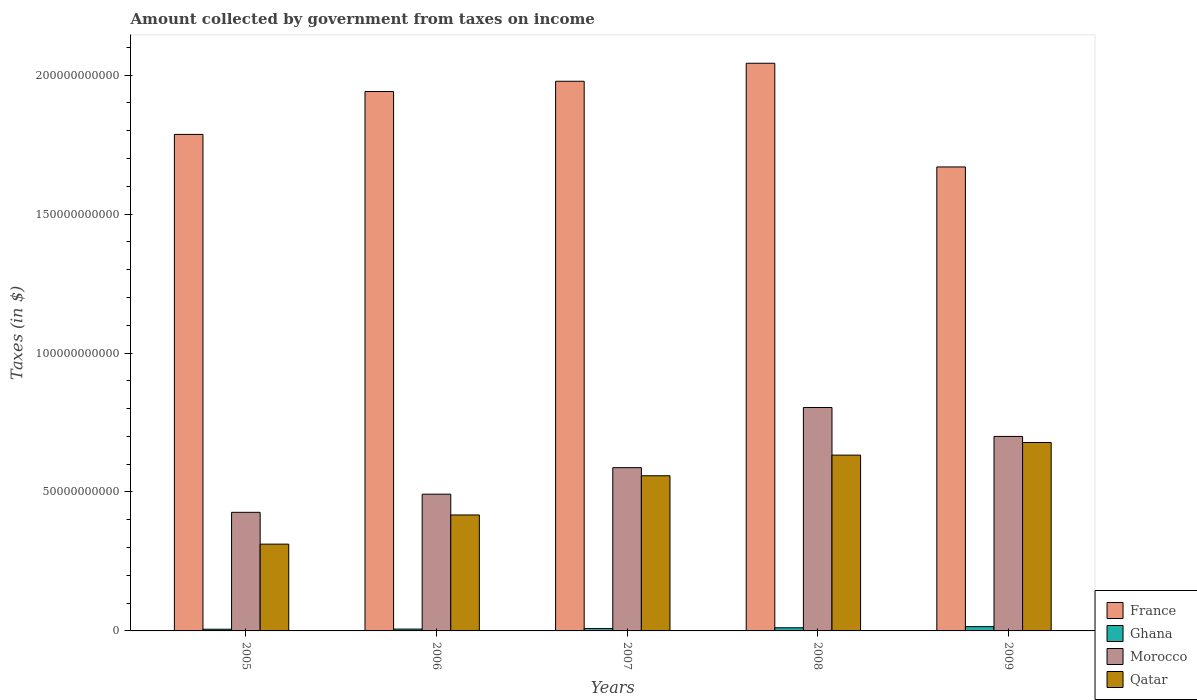How many different coloured bars are there?
Provide a succinct answer. 4. How many groups of bars are there?
Offer a very short reply. 5. How many bars are there on the 1st tick from the left?
Your answer should be compact. 4. How many bars are there on the 1st tick from the right?
Ensure brevity in your answer.  4. What is the label of the 4th group of bars from the left?
Give a very brief answer. 2008. What is the amount collected by government from taxes on income in Morocco in 2007?
Provide a succinct answer. 5.88e+1. Across all years, what is the maximum amount collected by government from taxes on income in Ghana?
Offer a very short reply. 1.54e+09. Across all years, what is the minimum amount collected by government from taxes on income in Morocco?
Your answer should be very brief. 4.27e+1. In which year was the amount collected by government from taxes on income in Morocco minimum?
Make the answer very short. 2005. What is the total amount collected by government from taxes on income in France in the graph?
Keep it short and to the point. 9.42e+11. What is the difference between the amount collected by government from taxes on income in France in 2006 and that in 2007?
Give a very brief answer. -3.69e+09. What is the difference between the amount collected by government from taxes on income in Morocco in 2008 and the amount collected by government from taxes on income in Qatar in 2005?
Keep it short and to the point. 4.92e+1. What is the average amount collected by government from taxes on income in Ghana per year?
Make the answer very short. 9.60e+08. In the year 2007, what is the difference between the amount collected by government from taxes on income in Morocco and amount collected by government from taxes on income in Qatar?
Provide a succinct answer. 2.91e+09. In how many years, is the amount collected by government from taxes on income in France greater than 140000000000 $?
Your answer should be compact. 5. What is the ratio of the amount collected by government from taxes on income in France in 2006 to that in 2007?
Your answer should be very brief. 0.98. What is the difference between the highest and the second highest amount collected by government from taxes on income in Morocco?
Your answer should be compact. 1.04e+1. What is the difference between the highest and the lowest amount collected by government from taxes on income in Morocco?
Make the answer very short. 3.77e+1. In how many years, is the amount collected by government from taxes on income in Qatar greater than the average amount collected by government from taxes on income in Qatar taken over all years?
Provide a succinct answer. 3. What does the 3rd bar from the left in 2006 represents?
Offer a terse response. Morocco. What does the 2nd bar from the right in 2008 represents?
Make the answer very short. Morocco. Is it the case that in every year, the sum of the amount collected by government from taxes on income in Ghana and amount collected by government from taxes on income in Morocco is greater than the amount collected by government from taxes on income in Qatar?
Keep it short and to the point. Yes. How many bars are there?
Your response must be concise. 20. Are all the bars in the graph horizontal?
Your answer should be compact. No. How many years are there in the graph?
Offer a terse response. 5. Does the graph contain grids?
Give a very brief answer. No. How many legend labels are there?
Offer a terse response. 4. How are the legend labels stacked?
Provide a short and direct response. Vertical. What is the title of the graph?
Ensure brevity in your answer.  Amount collected by government from taxes on income. What is the label or title of the X-axis?
Keep it short and to the point. Years. What is the label or title of the Y-axis?
Keep it short and to the point. Taxes (in $). What is the Taxes (in $) in France in 2005?
Make the answer very short. 1.79e+11. What is the Taxes (in $) in Ghana in 2005?
Provide a short and direct response. 6.09e+08. What is the Taxes (in $) in Morocco in 2005?
Ensure brevity in your answer.  4.27e+1. What is the Taxes (in $) of Qatar in 2005?
Make the answer very short. 3.12e+1. What is the Taxes (in $) of France in 2006?
Ensure brevity in your answer.  1.94e+11. What is the Taxes (in $) of Ghana in 2006?
Keep it short and to the point. 6.58e+08. What is the Taxes (in $) in Morocco in 2006?
Offer a very short reply. 4.92e+1. What is the Taxes (in $) in Qatar in 2006?
Your response must be concise. 4.17e+1. What is the Taxes (in $) in France in 2007?
Give a very brief answer. 1.98e+11. What is the Taxes (in $) in Ghana in 2007?
Provide a succinct answer. 8.57e+08. What is the Taxes (in $) in Morocco in 2007?
Your response must be concise. 5.88e+1. What is the Taxes (in $) in Qatar in 2007?
Give a very brief answer. 5.58e+1. What is the Taxes (in $) in France in 2008?
Your answer should be compact. 2.04e+11. What is the Taxes (in $) in Ghana in 2008?
Ensure brevity in your answer.  1.13e+09. What is the Taxes (in $) in Morocco in 2008?
Provide a succinct answer. 8.04e+1. What is the Taxes (in $) in Qatar in 2008?
Provide a short and direct response. 6.33e+1. What is the Taxes (in $) of France in 2009?
Ensure brevity in your answer.  1.67e+11. What is the Taxes (in $) of Ghana in 2009?
Your answer should be very brief. 1.54e+09. What is the Taxes (in $) in Morocco in 2009?
Provide a short and direct response. 7.00e+1. What is the Taxes (in $) in Qatar in 2009?
Offer a terse response. 6.78e+1. Across all years, what is the maximum Taxes (in $) of France?
Your answer should be compact. 2.04e+11. Across all years, what is the maximum Taxes (in $) of Ghana?
Offer a very short reply. 1.54e+09. Across all years, what is the maximum Taxes (in $) in Morocco?
Give a very brief answer. 8.04e+1. Across all years, what is the maximum Taxes (in $) in Qatar?
Your answer should be compact. 6.78e+1. Across all years, what is the minimum Taxes (in $) in France?
Your answer should be compact. 1.67e+11. Across all years, what is the minimum Taxes (in $) of Ghana?
Your answer should be compact. 6.09e+08. Across all years, what is the minimum Taxes (in $) of Morocco?
Your answer should be compact. 4.27e+1. Across all years, what is the minimum Taxes (in $) in Qatar?
Your answer should be very brief. 3.12e+1. What is the total Taxes (in $) in France in the graph?
Provide a short and direct response. 9.42e+11. What is the total Taxes (in $) of Ghana in the graph?
Your response must be concise. 4.80e+09. What is the total Taxes (in $) of Morocco in the graph?
Provide a short and direct response. 3.01e+11. What is the total Taxes (in $) of Qatar in the graph?
Keep it short and to the point. 2.60e+11. What is the difference between the Taxes (in $) in France in 2005 and that in 2006?
Make the answer very short. -1.54e+1. What is the difference between the Taxes (in $) of Ghana in 2005 and that in 2006?
Provide a short and direct response. -4.90e+07. What is the difference between the Taxes (in $) of Morocco in 2005 and that in 2006?
Your response must be concise. -6.53e+09. What is the difference between the Taxes (in $) of Qatar in 2005 and that in 2006?
Keep it short and to the point. -1.05e+1. What is the difference between the Taxes (in $) of France in 2005 and that in 2007?
Provide a short and direct response. -1.91e+1. What is the difference between the Taxes (in $) of Ghana in 2005 and that in 2007?
Keep it short and to the point. -2.48e+08. What is the difference between the Taxes (in $) in Morocco in 2005 and that in 2007?
Offer a very short reply. -1.61e+1. What is the difference between the Taxes (in $) of Qatar in 2005 and that in 2007?
Your response must be concise. -2.46e+1. What is the difference between the Taxes (in $) of France in 2005 and that in 2008?
Your response must be concise. -2.56e+1. What is the difference between the Taxes (in $) of Ghana in 2005 and that in 2008?
Keep it short and to the point. -5.26e+08. What is the difference between the Taxes (in $) of Morocco in 2005 and that in 2008?
Your answer should be very brief. -3.77e+1. What is the difference between the Taxes (in $) in Qatar in 2005 and that in 2008?
Your answer should be very brief. -3.20e+1. What is the difference between the Taxes (in $) of France in 2005 and that in 2009?
Give a very brief answer. 1.17e+1. What is the difference between the Taxes (in $) of Ghana in 2005 and that in 2009?
Offer a terse response. -9.29e+08. What is the difference between the Taxes (in $) of Morocco in 2005 and that in 2009?
Offer a terse response. -2.73e+1. What is the difference between the Taxes (in $) of Qatar in 2005 and that in 2009?
Your answer should be compact. -3.66e+1. What is the difference between the Taxes (in $) of France in 2006 and that in 2007?
Your response must be concise. -3.69e+09. What is the difference between the Taxes (in $) in Ghana in 2006 and that in 2007?
Your answer should be very brief. -1.99e+08. What is the difference between the Taxes (in $) of Morocco in 2006 and that in 2007?
Offer a very short reply. -9.54e+09. What is the difference between the Taxes (in $) of Qatar in 2006 and that in 2007?
Your answer should be very brief. -1.41e+1. What is the difference between the Taxes (in $) of France in 2006 and that in 2008?
Provide a succinct answer. -1.02e+1. What is the difference between the Taxes (in $) of Ghana in 2006 and that in 2008?
Offer a very short reply. -4.77e+08. What is the difference between the Taxes (in $) in Morocco in 2006 and that in 2008?
Ensure brevity in your answer.  -3.12e+1. What is the difference between the Taxes (in $) in Qatar in 2006 and that in 2008?
Your answer should be compact. -2.15e+1. What is the difference between the Taxes (in $) of France in 2006 and that in 2009?
Offer a very short reply. 2.71e+1. What is the difference between the Taxes (in $) of Ghana in 2006 and that in 2009?
Provide a succinct answer. -8.80e+08. What is the difference between the Taxes (in $) of Morocco in 2006 and that in 2009?
Your answer should be compact. -2.08e+1. What is the difference between the Taxes (in $) in Qatar in 2006 and that in 2009?
Your answer should be compact. -2.61e+1. What is the difference between the Taxes (in $) in France in 2007 and that in 2008?
Offer a very short reply. -6.48e+09. What is the difference between the Taxes (in $) of Ghana in 2007 and that in 2008?
Make the answer very short. -2.77e+08. What is the difference between the Taxes (in $) of Morocco in 2007 and that in 2008?
Offer a very short reply. -2.17e+1. What is the difference between the Taxes (in $) of Qatar in 2007 and that in 2008?
Ensure brevity in your answer.  -7.43e+09. What is the difference between the Taxes (in $) of France in 2007 and that in 2009?
Provide a succinct answer. 3.08e+1. What is the difference between the Taxes (in $) of Ghana in 2007 and that in 2009?
Provide a succinct answer. -6.81e+08. What is the difference between the Taxes (in $) in Morocco in 2007 and that in 2009?
Offer a terse response. -1.12e+1. What is the difference between the Taxes (in $) of Qatar in 2007 and that in 2009?
Provide a succinct answer. -1.20e+1. What is the difference between the Taxes (in $) of France in 2008 and that in 2009?
Make the answer very short. 3.73e+1. What is the difference between the Taxes (in $) of Ghana in 2008 and that in 2009?
Provide a short and direct response. -4.04e+08. What is the difference between the Taxes (in $) in Morocco in 2008 and that in 2009?
Your response must be concise. 1.04e+1. What is the difference between the Taxes (in $) of Qatar in 2008 and that in 2009?
Your response must be concise. -4.54e+09. What is the difference between the Taxes (in $) of France in 2005 and the Taxes (in $) of Ghana in 2006?
Make the answer very short. 1.78e+11. What is the difference between the Taxes (in $) of France in 2005 and the Taxes (in $) of Morocco in 2006?
Provide a succinct answer. 1.29e+11. What is the difference between the Taxes (in $) in France in 2005 and the Taxes (in $) in Qatar in 2006?
Ensure brevity in your answer.  1.37e+11. What is the difference between the Taxes (in $) of Ghana in 2005 and the Taxes (in $) of Morocco in 2006?
Offer a very short reply. -4.86e+1. What is the difference between the Taxes (in $) in Ghana in 2005 and the Taxes (in $) in Qatar in 2006?
Provide a succinct answer. -4.11e+1. What is the difference between the Taxes (in $) of Morocco in 2005 and the Taxes (in $) of Qatar in 2006?
Keep it short and to the point. 9.52e+08. What is the difference between the Taxes (in $) of France in 2005 and the Taxes (in $) of Ghana in 2007?
Ensure brevity in your answer.  1.78e+11. What is the difference between the Taxes (in $) in France in 2005 and the Taxes (in $) in Morocco in 2007?
Provide a succinct answer. 1.20e+11. What is the difference between the Taxes (in $) of France in 2005 and the Taxes (in $) of Qatar in 2007?
Make the answer very short. 1.23e+11. What is the difference between the Taxes (in $) of Ghana in 2005 and the Taxes (in $) of Morocco in 2007?
Keep it short and to the point. -5.81e+1. What is the difference between the Taxes (in $) of Ghana in 2005 and the Taxes (in $) of Qatar in 2007?
Offer a terse response. -5.52e+1. What is the difference between the Taxes (in $) in Morocco in 2005 and the Taxes (in $) in Qatar in 2007?
Your answer should be compact. -1.32e+1. What is the difference between the Taxes (in $) of France in 2005 and the Taxes (in $) of Ghana in 2008?
Make the answer very short. 1.78e+11. What is the difference between the Taxes (in $) in France in 2005 and the Taxes (in $) in Morocco in 2008?
Your answer should be compact. 9.83e+1. What is the difference between the Taxes (in $) in France in 2005 and the Taxes (in $) in Qatar in 2008?
Offer a very short reply. 1.15e+11. What is the difference between the Taxes (in $) of Ghana in 2005 and the Taxes (in $) of Morocco in 2008?
Your response must be concise. -7.98e+1. What is the difference between the Taxes (in $) of Ghana in 2005 and the Taxes (in $) of Qatar in 2008?
Your answer should be very brief. -6.27e+1. What is the difference between the Taxes (in $) of Morocco in 2005 and the Taxes (in $) of Qatar in 2008?
Your answer should be very brief. -2.06e+1. What is the difference between the Taxes (in $) of France in 2005 and the Taxes (in $) of Ghana in 2009?
Keep it short and to the point. 1.77e+11. What is the difference between the Taxes (in $) in France in 2005 and the Taxes (in $) in Morocco in 2009?
Ensure brevity in your answer.  1.09e+11. What is the difference between the Taxes (in $) of France in 2005 and the Taxes (in $) of Qatar in 2009?
Ensure brevity in your answer.  1.11e+11. What is the difference between the Taxes (in $) in Ghana in 2005 and the Taxes (in $) in Morocco in 2009?
Ensure brevity in your answer.  -6.94e+1. What is the difference between the Taxes (in $) in Ghana in 2005 and the Taxes (in $) in Qatar in 2009?
Keep it short and to the point. -6.72e+1. What is the difference between the Taxes (in $) in Morocco in 2005 and the Taxes (in $) in Qatar in 2009?
Give a very brief answer. -2.51e+1. What is the difference between the Taxes (in $) of France in 2006 and the Taxes (in $) of Ghana in 2007?
Provide a short and direct response. 1.93e+11. What is the difference between the Taxes (in $) in France in 2006 and the Taxes (in $) in Morocco in 2007?
Provide a short and direct response. 1.35e+11. What is the difference between the Taxes (in $) of France in 2006 and the Taxes (in $) of Qatar in 2007?
Your answer should be very brief. 1.38e+11. What is the difference between the Taxes (in $) of Ghana in 2006 and the Taxes (in $) of Morocco in 2007?
Give a very brief answer. -5.81e+1. What is the difference between the Taxes (in $) in Ghana in 2006 and the Taxes (in $) in Qatar in 2007?
Make the answer very short. -5.52e+1. What is the difference between the Taxes (in $) in Morocco in 2006 and the Taxes (in $) in Qatar in 2007?
Your answer should be compact. -6.63e+09. What is the difference between the Taxes (in $) in France in 2006 and the Taxes (in $) in Ghana in 2008?
Make the answer very short. 1.93e+11. What is the difference between the Taxes (in $) of France in 2006 and the Taxes (in $) of Morocco in 2008?
Your answer should be very brief. 1.14e+11. What is the difference between the Taxes (in $) in France in 2006 and the Taxes (in $) in Qatar in 2008?
Give a very brief answer. 1.31e+11. What is the difference between the Taxes (in $) in Ghana in 2006 and the Taxes (in $) in Morocco in 2008?
Provide a short and direct response. -7.97e+1. What is the difference between the Taxes (in $) in Ghana in 2006 and the Taxes (in $) in Qatar in 2008?
Offer a very short reply. -6.26e+1. What is the difference between the Taxes (in $) of Morocco in 2006 and the Taxes (in $) of Qatar in 2008?
Your response must be concise. -1.41e+1. What is the difference between the Taxes (in $) of France in 2006 and the Taxes (in $) of Ghana in 2009?
Keep it short and to the point. 1.93e+11. What is the difference between the Taxes (in $) of France in 2006 and the Taxes (in $) of Morocco in 2009?
Give a very brief answer. 1.24e+11. What is the difference between the Taxes (in $) of France in 2006 and the Taxes (in $) of Qatar in 2009?
Ensure brevity in your answer.  1.26e+11. What is the difference between the Taxes (in $) of Ghana in 2006 and the Taxes (in $) of Morocco in 2009?
Make the answer very short. -6.93e+1. What is the difference between the Taxes (in $) in Ghana in 2006 and the Taxes (in $) in Qatar in 2009?
Your answer should be very brief. -6.72e+1. What is the difference between the Taxes (in $) in Morocco in 2006 and the Taxes (in $) in Qatar in 2009?
Your answer should be very brief. -1.86e+1. What is the difference between the Taxes (in $) of France in 2007 and the Taxes (in $) of Ghana in 2008?
Your answer should be compact. 1.97e+11. What is the difference between the Taxes (in $) of France in 2007 and the Taxes (in $) of Morocco in 2008?
Provide a succinct answer. 1.17e+11. What is the difference between the Taxes (in $) in France in 2007 and the Taxes (in $) in Qatar in 2008?
Give a very brief answer. 1.35e+11. What is the difference between the Taxes (in $) in Ghana in 2007 and the Taxes (in $) in Morocco in 2008?
Provide a succinct answer. -7.95e+1. What is the difference between the Taxes (in $) in Ghana in 2007 and the Taxes (in $) in Qatar in 2008?
Provide a succinct answer. -6.24e+1. What is the difference between the Taxes (in $) of Morocco in 2007 and the Taxes (in $) of Qatar in 2008?
Give a very brief answer. -4.52e+09. What is the difference between the Taxes (in $) of France in 2007 and the Taxes (in $) of Ghana in 2009?
Ensure brevity in your answer.  1.96e+11. What is the difference between the Taxes (in $) of France in 2007 and the Taxes (in $) of Morocco in 2009?
Offer a terse response. 1.28e+11. What is the difference between the Taxes (in $) in France in 2007 and the Taxes (in $) in Qatar in 2009?
Keep it short and to the point. 1.30e+11. What is the difference between the Taxes (in $) in Ghana in 2007 and the Taxes (in $) in Morocco in 2009?
Provide a succinct answer. -6.91e+1. What is the difference between the Taxes (in $) of Ghana in 2007 and the Taxes (in $) of Qatar in 2009?
Keep it short and to the point. -6.70e+1. What is the difference between the Taxes (in $) of Morocco in 2007 and the Taxes (in $) of Qatar in 2009?
Make the answer very short. -9.06e+09. What is the difference between the Taxes (in $) in France in 2008 and the Taxes (in $) in Ghana in 2009?
Ensure brevity in your answer.  2.03e+11. What is the difference between the Taxes (in $) in France in 2008 and the Taxes (in $) in Morocco in 2009?
Make the answer very short. 1.34e+11. What is the difference between the Taxes (in $) in France in 2008 and the Taxes (in $) in Qatar in 2009?
Keep it short and to the point. 1.36e+11. What is the difference between the Taxes (in $) of Ghana in 2008 and the Taxes (in $) of Morocco in 2009?
Offer a terse response. -6.89e+1. What is the difference between the Taxes (in $) of Ghana in 2008 and the Taxes (in $) of Qatar in 2009?
Keep it short and to the point. -6.67e+1. What is the difference between the Taxes (in $) of Morocco in 2008 and the Taxes (in $) of Qatar in 2009?
Ensure brevity in your answer.  1.26e+1. What is the average Taxes (in $) in France per year?
Offer a terse response. 1.88e+11. What is the average Taxes (in $) in Ghana per year?
Your answer should be compact. 9.60e+08. What is the average Taxes (in $) of Morocco per year?
Your answer should be very brief. 6.02e+1. What is the average Taxes (in $) of Qatar per year?
Your answer should be very brief. 5.20e+1. In the year 2005, what is the difference between the Taxes (in $) of France and Taxes (in $) of Ghana?
Keep it short and to the point. 1.78e+11. In the year 2005, what is the difference between the Taxes (in $) in France and Taxes (in $) in Morocco?
Offer a terse response. 1.36e+11. In the year 2005, what is the difference between the Taxes (in $) of France and Taxes (in $) of Qatar?
Make the answer very short. 1.47e+11. In the year 2005, what is the difference between the Taxes (in $) of Ghana and Taxes (in $) of Morocco?
Provide a short and direct response. -4.21e+1. In the year 2005, what is the difference between the Taxes (in $) in Ghana and Taxes (in $) in Qatar?
Your response must be concise. -3.06e+1. In the year 2005, what is the difference between the Taxes (in $) in Morocco and Taxes (in $) in Qatar?
Provide a short and direct response. 1.14e+1. In the year 2006, what is the difference between the Taxes (in $) of France and Taxes (in $) of Ghana?
Make the answer very short. 1.93e+11. In the year 2006, what is the difference between the Taxes (in $) of France and Taxes (in $) of Morocco?
Offer a very short reply. 1.45e+11. In the year 2006, what is the difference between the Taxes (in $) of France and Taxes (in $) of Qatar?
Your response must be concise. 1.52e+11. In the year 2006, what is the difference between the Taxes (in $) of Ghana and Taxes (in $) of Morocco?
Offer a very short reply. -4.86e+1. In the year 2006, what is the difference between the Taxes (in $) of Ghana and Taxes (in $) of Qatar?
Keep it short and to the point. -4.11e+1. In the year 2006, what is the difference between the Taxes (in $) of Morocco and Taxes (in $) of Qatar?
Your answer should be compact. 7.48e+09. In the year 2007, what is the difference between the Taxes (in $) in France and Taxes (in $) in Ghana?
Give a very brief answer. 1.97e+11. In the year 2007, what is the difference between the Taxes (in $) in France and Taxes (in $) in Morocco?
Provide a succinct answer. 1.39e+11. In the year 2007, what is the difference between the Taxes (in $) of France and Taxes (in $) of Qatar?
Provide a short and direct response. 1.42e+11. In the year 2007, what is the difference between the Taxes (in $) of Ghana and Taxes (in $) of Morocco?
Offer a terse response. -5.79e+1. In the year 2007, what is the difference between the Taxes (in $) in Ghana and Taxes (in $) in Qatar?
Provide a short and direct response. -5.50e+1. In the year 2007, what is the difference between the Taxes (in $) of Morocco and Taxes (in $) of Qatar?
Ensure brevity in your answer.  2.91e+09. In the year 2008, what is the difference between the Taxes (in $) of France and Taxes (in $) of Ghana?
Your answer should be compact. 2.03e+11. In the year 2008, what is the difference between the Taxes (in $) of France and Taxes (in $) of Morocco?
Your answer should be compact. 1.24e+11. In the year 2008, what is the difference between the Taxes (in $) in France and Taxes (in $) in Qatar?
Offer a very short reply. 1.41e+11. In the year 2008, what is the difference between the Taxes (in $) of Ghana and Taxes (in $) of Morocco?
Keep it short and to the point. -7.93e+1. In the year 2008, what is the difference between the Taxes (in $) of Ghana and Taxes (in $) of Qatar?
Your answer should be very brief. -6.21e+1. In the year 2008, what is the difference between the Taxes (in $) of Morocco and Taxes (in $) of Qatar?
Make the answer very short. 1.71e+1. In the year 2009, what is the difference between the Taxes (in $) of France and Taxes (in $) of Ghana?
Provide a succinct answer. 1.65e+11. In the year 2009, what is the difference between the Taxes (in $) of France and Taxes (in $) of Morocco?
Keep it short and to the point. 9.70e+1. In the year 2009, what is the difference between the Taxes (in $) of France and Taxes (in $) of Qatar?
Offer a very short reply. 9.92e+1. In the year 2009, what is the difference between the Taxes (in $) of Ghana and Taxes (in $) of Morocco?
Keep it short and to the point. -6.85e+1. In the year 2009, what is the difference between the Taxes (in $) in Ghana and Taxes (in $) in Qatar?
Make the answer very short. -6.63e+1. In the year 2009, what is the difference between the Taxes (in $) of Morocco and Taxes (in $) of Qatar?
Provide a succinct answer. 2.18e+09. What is the ratio of the Taxes (in $) of France in 2005 to that in 2006?
Provide a succinct answer. 0.92. What is the ratio of the Taxes (in $) in Ghana in 2005 to that in 2006?
Make the answer very short. 0.93. What is the ratio of the Taxes (in $) of Morocco in 2005 to that in 2006?
Offer a terse response. 0.87. What is the ratio of the Taxes (in $) in Qatar in 2005 to that in 2006?
Offer a terse response. 0.75. What is the ratio of the Taxes (in $) in France in 2005 to that in 2007?
Your answer should be very brief. 0.9. What is the ratio of the Taxes (in $) in Ghana in 2005 to that in 2007?
Offer a terse response. 0.71. What is the ratio of the Taxes (in $) in Morocco in 2005 to that in 2007?
Your response must be concise. 0.73. What is the ratio of the Taxes (in $) of Qatar in 2005 to that in 2007?
Ensure brevity in your answer.  0.56. What is the ratio of the Taxes (in $) of France in 2005 to that in 2008?
Provide a short and direct response. 0.87. What is the ratio of the Taxes (in $) of Ghana in 2005 to that in 2008?
Your answer should be compact. 0.54. What is the ratio of the Taxes (in $) of Morocco in 2005 to that in 2008?
Provide a short and direct response. 0.53. What is the ratio of the Taxes (in $) of Qatar in 2005 to that in 2008?
Offer a very short reply. 0.49. What is the ratio of the Taxes (in $) of France in 2005 to that in 2009?
Provide a short and direct response. 1.07. What is the ratio of the Taxes (in $) in Ghana in 2005 to that in 2009?
Offer a terse response. 0.4. What is the ratio of the Taxes (in $) in Morocco in 2005 to that in 2009?
Your answer should be compact. 0.61. What is the ratio of the Taxes (in $) in Qatar in 2005 to that in 2009?
Make the answer very short. 0.46. What is the ratio of the Taxes (in $) in France in 2006 to that in 2007?
Offer a very short reply. 0.98. What is the ratio of the Taxes (in $) of Ghana in 2006 to that in 2007?
Offer a terse response. 0.77. What is the ratio of the Taxes (in $) of Morocco in 2006 to that in 2007?
Keep it short and to the point. 0.84. What is the ratio of the Taxes (in $) in Qatar in 2006 to that in 2007?
Offer a very short reply. 0.75. What is the ratio of the Taxes (in $) in France in 2006 to that in 2008?
Provide a succinct answer. 0.95. What is the ratio of the Taxes (in $) in Ghana in 2006 to that in 2008?
Make the answer very short. 0.58. What is the ratio of the Taxes (in $) in Morocco in 2006 to that in 2008?
Your answer should be compact. 0.61. What is the ratio of the Taxes (in $) of Qatar in 2006 to that in 2008?
Your answer should be compact. 0.66. What is the ratio of the Taxes (in $) in France in 2006 to that in 2009?
Your answer should be compact. 1.16. What is the ratio of the Taxes (in $) of Ghana in 2006 to that in 2009?
Offer a very short reply. 0.43. What is the ratio of the Taxes (in $) of Morocco in 2006 to that in 2009?
Give a very brief answer. 0.7. What is the ratio of the Taxes (in $) of Qatar in 2006 to that in 2009?
Offer a very short reply. 0.62. What is the ratio of the Taxes (in $) in France in 2007 to that in 2008?
Make the answer very short. 0.97. What is the ratio of the Taxes (in $) in Ghana in 2007 to that in 2008?
Give a very brief answer. 0.76. What is the ratio of the Taxes (in $) of Morocco in 2007 to that in 2008?
Make the answer very short. 0.73. What is the ratio of the Taxes (in $) in Qatar in 2007 to that in 2008?
Keep it short and to the point. 0.88. What is the ratio of the Taxes (in $) in France in 2007 to that in 2009?
Provide a short and direct response. 1.18. What is the ratio of the Taxes (in $) of Ghana in 2007 to that in 2009?
Your response must be concise. 0.56. What is the ratio of the Taxes (in $) of Morocco in 2007 to that in 2009?
Provide a short and direct response. 0.84. What is the ratio of the Taxes (in $) of Qatar in 2007 to that in 2009?
Offer a terse response. 0.82. What is the ratio of the Taxes (in $) of France in 2008 to that in 2009?
Provide a succinct answer. 1.22. What is the ratio of the Taxes (in $) of Ghana in 2008 to that in 2009?
Your answer should be very brief. 0.74. What is the ratio of the Taxes (in $) of Morocco in 2008 to that in 2009?
Your answer should be very brief. 1.15. What is the ratio of the Taxes (in $) of Qatar in 2008 to that in 2009?
Provide a succinct answer. 0.93. What is the difference between the highest and the second highest Taxes (in $) of France?
Make the answer very short. 6.48e+09. What is the difference between the highest and the second highest Taxes (in $) in Ghana?
Provide a succinct answer. 4.04e+08. What is the difference between the highest and the second highest Taxes (in $) in Morocco?
Your answer should be very brief. 1.04e+1. What is the difference between the highest and the second highest Taxes (in $) of Qatar?
Provide a short and direct response. 4.54e+09. What is the difference between the highest and the lowest Taxes (in $) in France?
Your answer should be compact. 3.73e+1. What is the difference between the highest and the lowest Taxes (in $) in Ghana?
Provide a short and direct response. 9.29e+08. What is the difference between the highest and the lowest Taxes (in $) of Morocco?
Your response must be concise. 3.77e+1. What is the difference between the highest and the lowest Taxes (in $) in Qatar?
Your answer should be compact. 3.66e+1. 